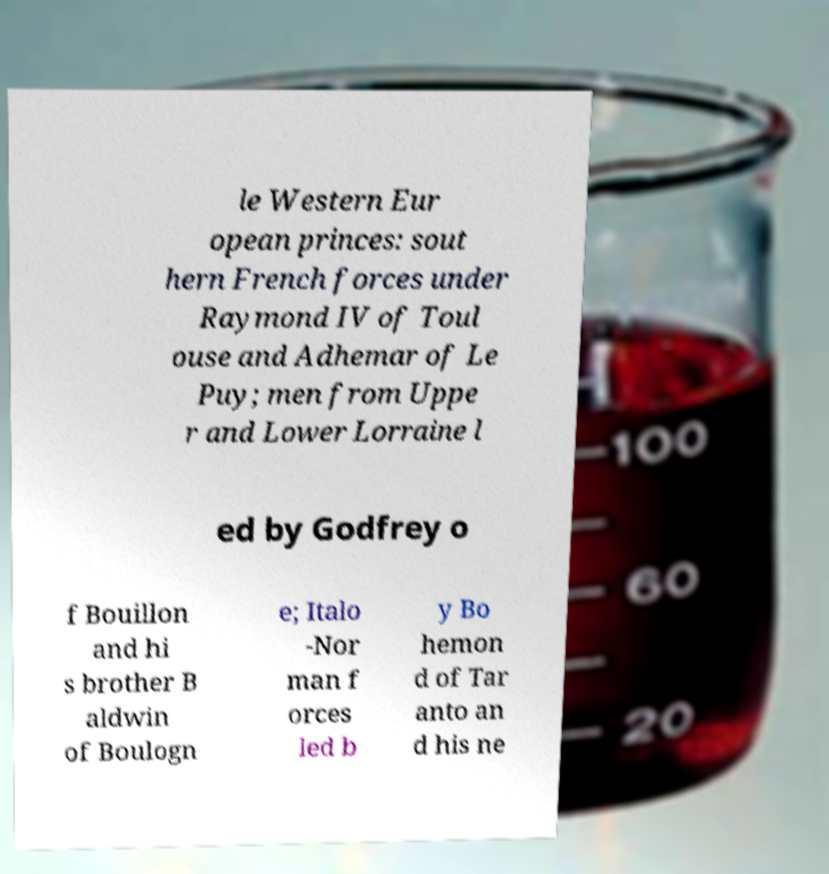Can you accurately transcribe the text from the provided image for me? le Western Eur opean princes: sout hern French forces under Raymond IV of Toul ouse and Adhemar of Le Puy; men from Uppe r and Lower Lorraine l ed by Godfrey o f Bouillon and hi s brother B aldwin of Boulogn e; Italo -Nor man f orces led b y Bo hemon d of Tar anto an d his ne 